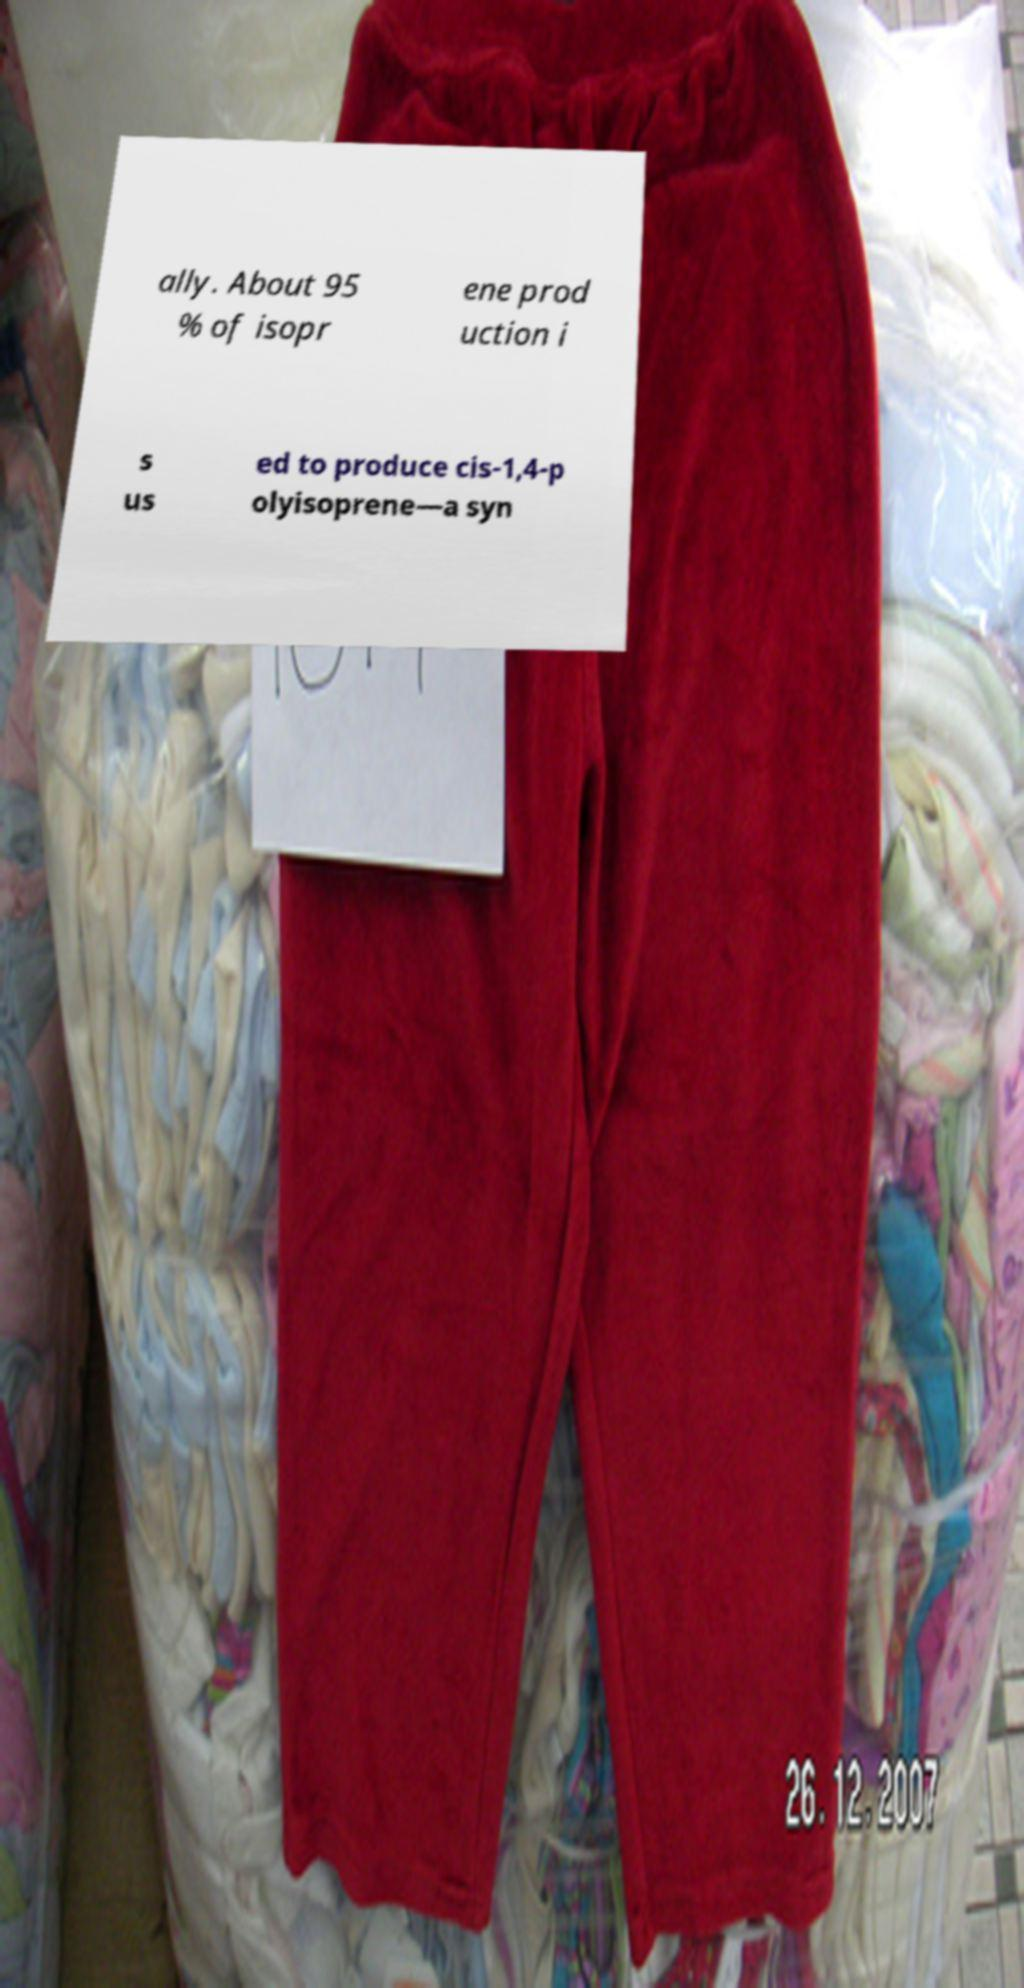Could you extract and type out the text from this image? ally. About 95 % of isopr ene prod uction i s us ed to produce cis-1,4-p olyisoprene—a syn 